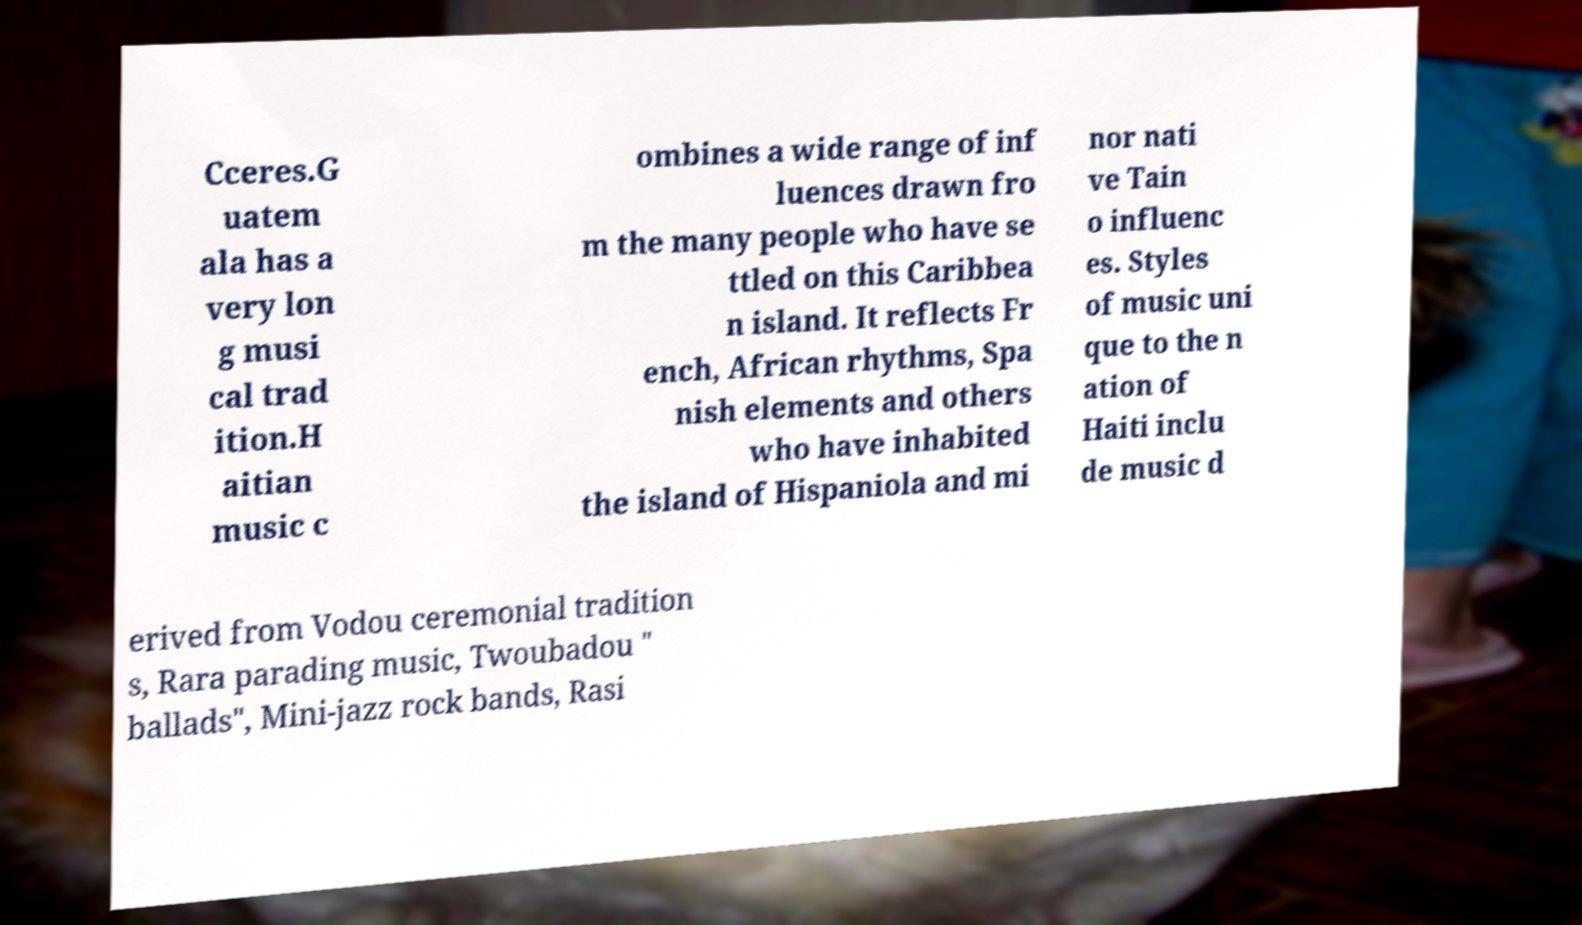For documentation purposes, I need the text within this image transcribed. Could you provide that? Cceres.G uatem ala has a very lon g musi cal trad ition.H aitian music c ombines a wide range of inf luences drawn fro m the many people who have se ttled on this Caribbea n island. It reflects Fr ench, African rhythms, Spa nish elements and others who have inhabited the island of Hispaniola and mi nor nati ve Tain o influenc es. Styles of music uni que to the n ation of Haiti inclu de music d erived from Vodou ceremonial tradition s, Rara parading music, Twoubadou " ballads", Mini-jazz rock bands, Rasi 